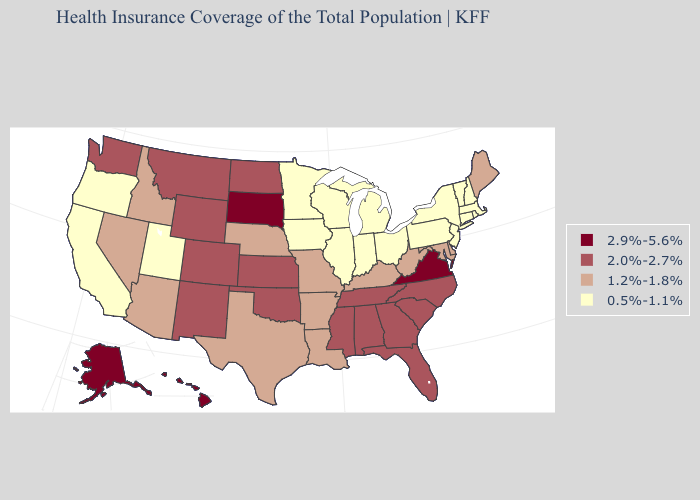Which states have the lowest value in the MidWest?
Write a very short answer. Illinois, Indiana, Iowa, Michigan, Minnesota, Ohio, Wisconsin. Does Montana have a higher value than Hawaii?
Concise answer only. No. What is the lowest value in the Northeast?
Answer briefly. 0.5%-1.1%. Name the states that have a value in the range 2.0%-2.7%?
Quick response, please. Alabama, Colorado, Florida, Georgia, Kansas, Mississippi, Montana, New Mexico, North Carolina, North Dakota, Oklahoma, South Carolina, Tennessee, Washington, Wyoming. What is the highest value in the South ?
Be succinct. 2.9%-5.6%. What is the value of Connecticut?
Answer briefly. 0.5%-1.1%. What is the value of Mississippi?
Give a very brief answer. 2.0%-2.7%. Does Rhode Island have the lowest value in the Northeast?
Short answer required. Yes. Does Maryland have the lowest value in the South?
Answer briefly. Yes. Does Massachusetts have a higher value than Florida?
Be succinct. No. Does Iowa have the lowest value in the USA?
Give a very brief answer. Yes. Among the states that border South Dakota , does North Dakota have the highest value?
Give a very brief answer. Yes. Name the states that have a value in the range 0.5%-1.1%?
Concise answer only. California, Connecticut, Illinois, Indiana, Iowa, Massachusetts, Michigan, Minnesota, New Hampshire, New Jersey, New York, Ohio, Oregon, Pennsylvania, Rhode Island, Utah, Vermont, Wisconsin. What is the value of Alaska?
Short answer required. 2.9%-5.6%. Which states hav the highest value in the West?
Write a very short answer. Alaska, Hawaii. 